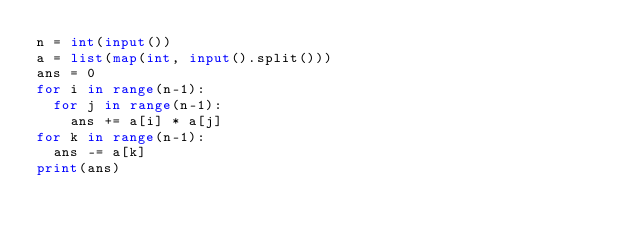Convert code to text. <code><loc_0><loc_0><loc_500><loc_500><_Python_>n = int(input())
a = list(map(int, input().split()))
ans = 0
for i in range(n-1):
  for j in range(n-1):
    ans += a[i] * a[j]
for k in range(n-1):
  ans -= a[k]
print(ans)</code> 